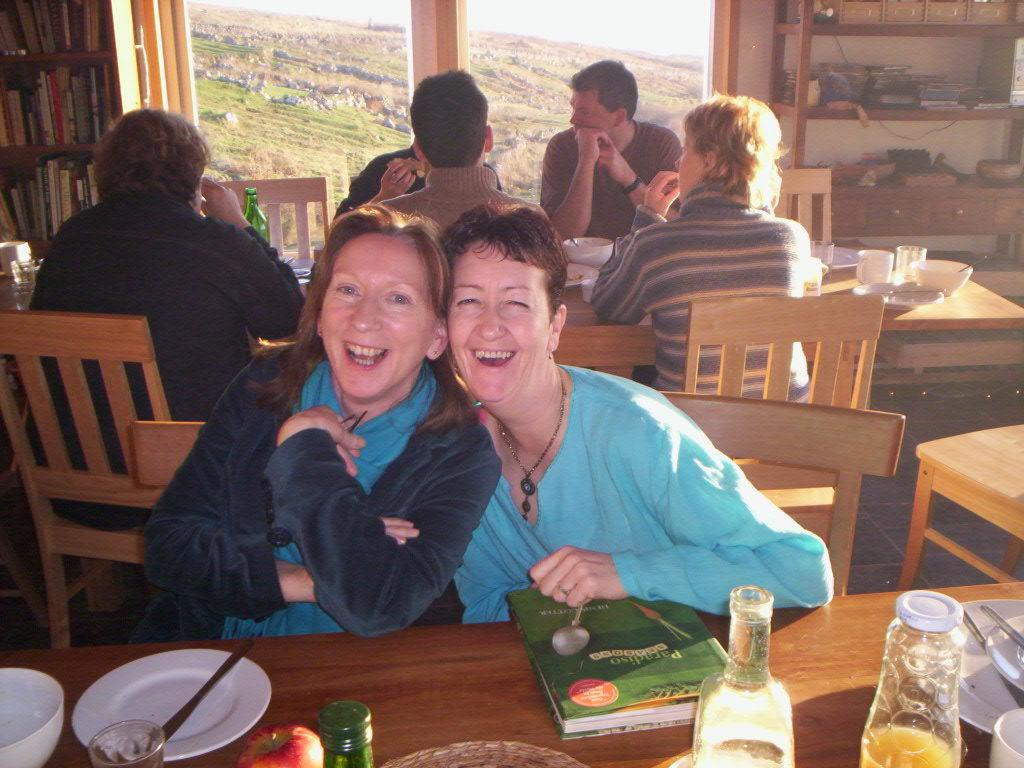What is the woman in the image doing? The woman is sitting on a chair in the image. Can you describe the setting of the image? There are people sitting on chairs in the background of the image. What type of account does the woman have with the appliance in the image? There is no appliance present in the image, and therefore no account can be associated with it. 